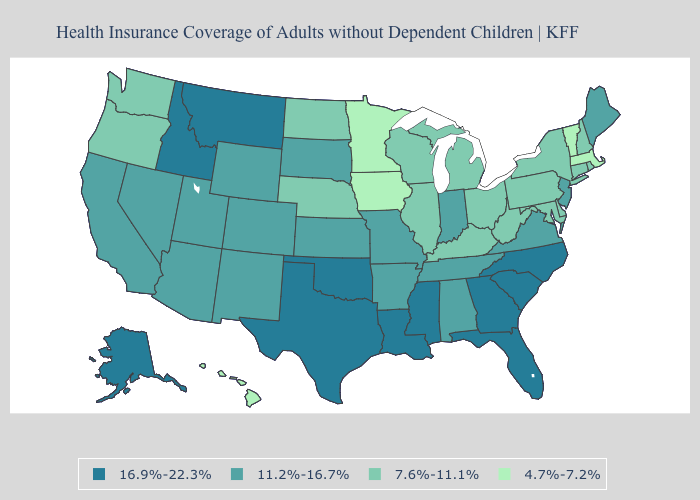How many symbols are there in the legend?
Give a very brief answer. 4. Does Minnesota have the same value as Wisconsin?
Write a very short answer. No. Name the states that have a value in the range 4.7%-7.2%?
Quick response, please. Hawaii, Iowa, Massachusetts, Minnesota, Vermont. What is the highest value in the MidWest ?
Answer briefly. 11.2%-16.7%. Does Mississippi have the highest value in the USA?
Be succinct. Yes. Name the states that have a value in the range 16.9%-22.3%?
Be succinct. Alaska, Florida, Georgia, Idaho, Louisiana, Mississippi, Montana, North Carolina, Oklahoma, South Carolina, Texas. What is the value of Nevada?
Answer briefly. 11.2%-16.7%. Name the states that have a value in the range 16.9%-22.3%?
Be succinct. Alaska, Florida, Georgia, Idaho, Louisiana, Mississippi, Montana, North Carolina, Oklahoma, South Carolina, Texas. Does New Hampshire have a lower value than Ohio?
Concise answer only. No. What is the value of Tennessee?
Keep it brief. 11.2%-16.7%. Does the first symbol in the legend represent the smallest category?
Write a very short answer. No. Among the states that border Nevada , which have the lowest value?
Write a very short answer. Oregon. Does Indiana have the highest value in the USA?
Give a very brief answer. No. What is the highest value in the West ?
Short answer required. 16.9%-22.3%. What is the lowest value in the USA?
Be succinct. 4.7%-7.2%. 